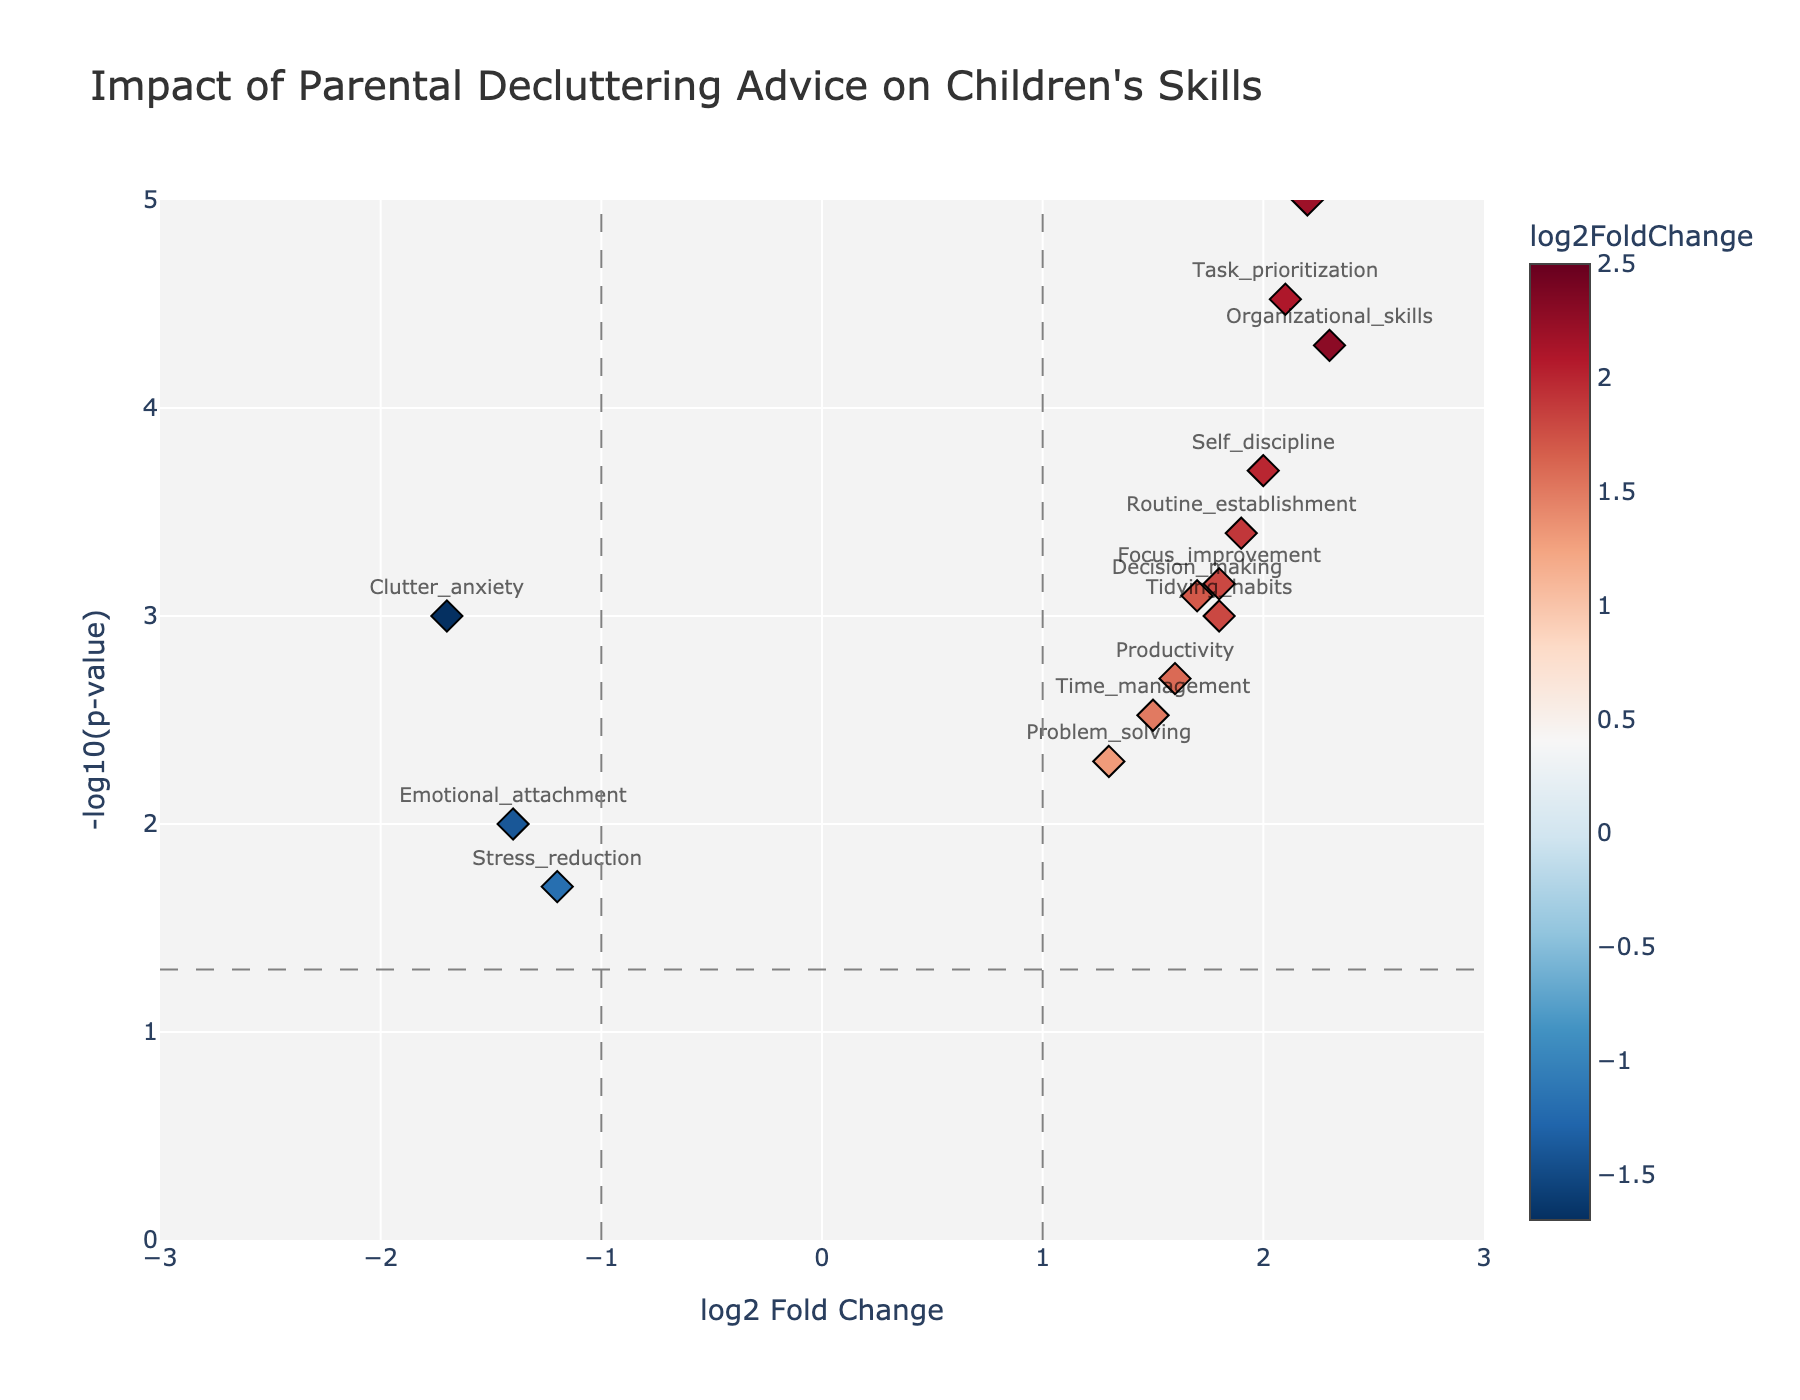What is the title of the plot? The title of the plot is usually found at the top of the figure. In this case, it reads "Impact of Parental Decluttering Advice on Children's Skills".
Answer: Impact of Parental Decluttering Advice on Children's Skills Which gene has the highest -log10(p-value)? By looking at the y-axis representing -log10(p-value), the gene that is positioned highest on the plot is "Space_optimization".
Answer: Space_optimization How many genes have a log2FoldChange greater than 2? To answer this, you need to count the data points on the plot where the x-axis value (log2FoldChange) is greater than 2. These genes are "Organizational_skills", "Task_prioritization", "Space_optimization", and "Minimalism_awareness".
Answer: 4 Which genes have a negative log2FoldChange? Negative log2FoldChange values are those left of 0 on the x-axis. The genes are "Stress_reduction", "Emotional_attachment", and "Clutter_anxiety".
Answer: Stress_reduction, Emotional_attachment, Clutter_anxiety What is the log2FoldChange and p-value of "Self_discipline"? Locate "Self_discipline" on the plot and refer to the hovertext or position. The gene "Self_discipline" has a log2FoldChange of 2.0 and a p-value indicated by its y-axis position.
Answer: log2FoldChange: 2.0, p-value: 0.0002 Which gene shows the greatest increase in skills due to parental decluttering advice? The gene with the highest log2FoldChange represents the greatest increase in skills. In this case, it's "Space_optimization" with a log2FoldChange of 2.5.
Answer: Space_optimization Exclude "Clutter_anxiety", which genes have a -log10(p-value) greater than 2.5? Looking at the y-axis, exclude "Clutter_anxiety" and identify the genes above the 2.5 mark. These are "Organizational_skills", "Task_prioritization", "Space_optimization", "Routine_establishment", "Self_discipline", and "Minimalism_awareness".
Answer: Organizational_skills, Task_prioritization, Space_optimization, Routine_establishment, Self_discipline, Minimalism_awareness Compare the p-values of "Emotional_attachment" and "Focus_improvement." Which one is smaller? Observe the y-axis positions of these genes. "-log10(p-value)" indicates smaller p-values are higher on the plot. "Focus_improvement" is positioned higher than "Emotional_attachment", indicating it has a smaller p-value.
Answer: Focus_improvement What does a log2FoldChange of 1.0 indicate on this plot? A log2FoldChange of 1.0 represents a doubling of the measured effect between those who received guidance and those who didn't. This can be seen around the value of 1 on the x-axis.
Answer: Doubling of the measured effect Which genes would be considered significant based on both log2FoldChange and -log10(p-value)? Considering significance as a log2FoldChange greater than 1 and a p-value less than 0.005, the genes meeting these criteria are: "Tidying_habits", "Organizational_skills", "Time_management", "Decision_making", "Task_prioritization", "Space_optimization", "Routine_establishment", "Self_discipline", "Productivity", "Minimalism_awareness", "Focus_improvement".
Answer: Tidying_habits, Organizational_skills, Time_management, Decision_making, Task_prioritization, Space_optimization, Routine_establishment, Self_discipline, Productivity, Minimalism_awareness, Focus_improvement 